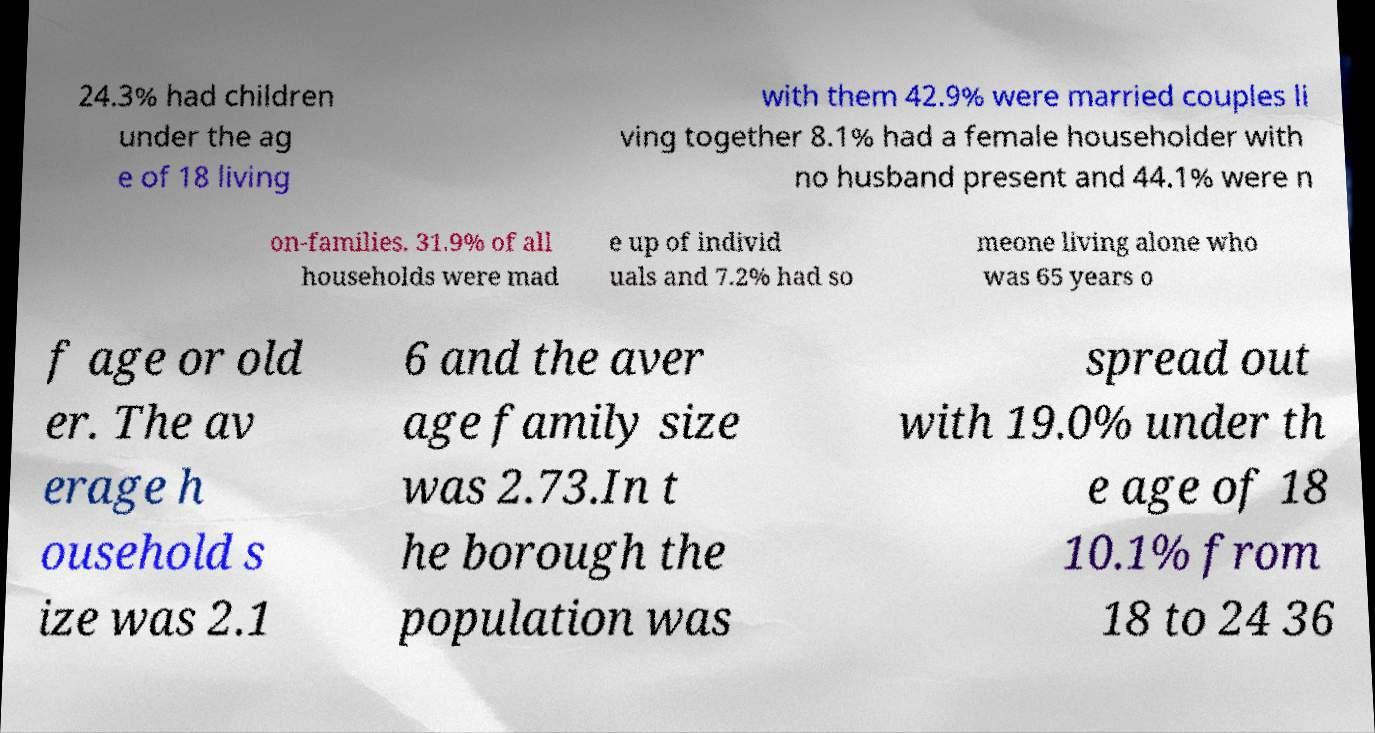There's text embedded in this image that I need extracted. Can you transcribe it verbatim? 24.3% had children under the ag e of 18 living with them 42.9% were married couples li ving together 8.1% had a female householder with no husband present and 44.1% were n on-families. 31.9% of all households were mad e up of individ uals and 7.2% had so meone living alone who was 65 years o f age or old er. The av erage h ousehold s ize was 2.1 6 and the aver age family size was 2.73.In t he borough the population was spread out with 19.0% under th e age of 18 10.1% from 18 to 24 36 